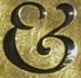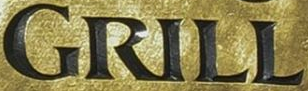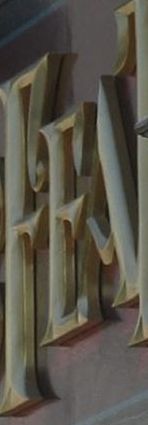What text is displayed in these images sequentially, separated by a semicolon? &; GRILL; FEA 